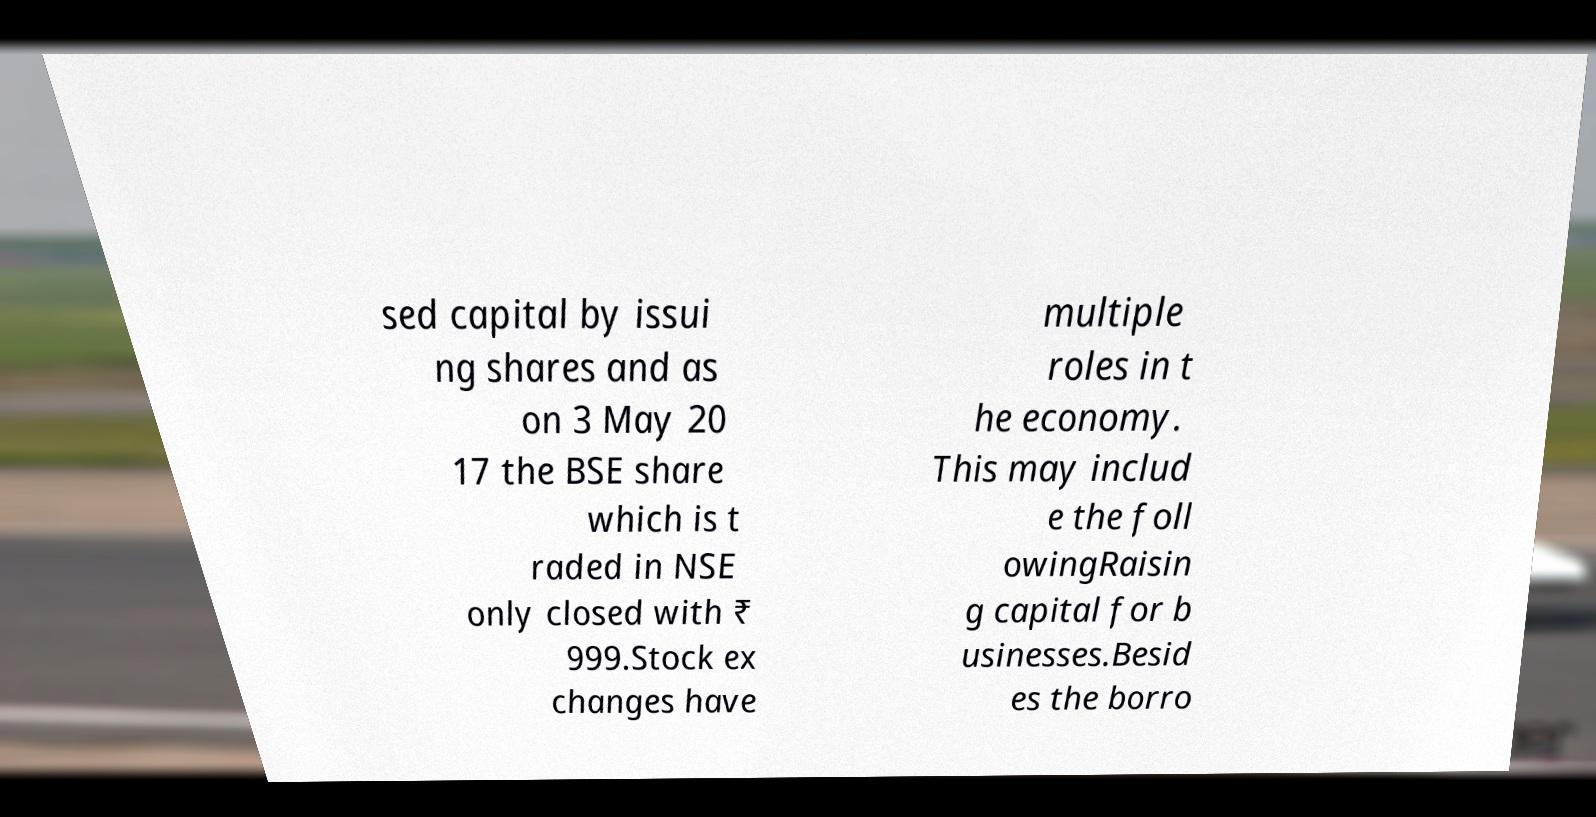Could you assist in decoding the text presented in this image and type it out clearly? sed capital by issui ng shares and as on 3 May 20 17 the BSE share which is t raded in NSE only closed with ₹ 999.Stock ex changes have multiple roles in t he economy. This may includ e the foll owingRaisin g capital for b usinesses.Besid es the borro 